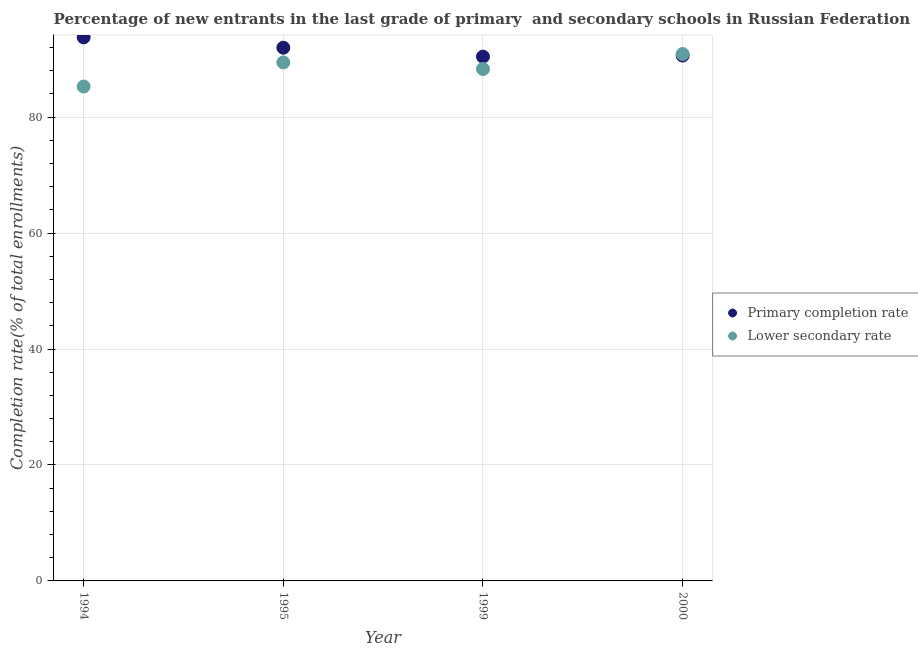How many different coloured dotlines are there?
Keep it short and to the point. 2. Is the number of dotlines equal to the number of legend labels?
Make the answer very short. Yes. What is the completion rate in secondary schools in 1999?
Give a very brief answer. 88.31. Across all years, what is the maximum completion rate in secondary schools?
Keep it short and to the point. 90.9. Across all years, what is the minimum completion rate in primary schools?
Offer a terse response. 90.45. In which year was the completion rate in primary schools maximum?
Give a very brief answer. 1994. In which year was the completion rate in secondary schools minimum?
Give a very brief answer. 1994. What is the total completion rate in primary schools in the graph?
Provide a succinct answer. 366.83. What is the difference between the completion rate in secondary schools in 1995 and that in 2000?
Your answer should be very brief. -1.45. What is the difference between the completion rate in primary schools in 1994 and the completion rate in secondary schools in 2000?
Offer a very short reply. 2.88. What is the average completion rate in secondary schools per year?
Make the answer very short. 88.49. In the year 2000, what is the difference between the completion rate in secondary schools and completion rate in primary schools?
Keep it short and to the point. 0.26. In how many years, is the completion rate in secondary schools greater than 68 %?
Offer a very short reply. 4. What is the ratio of the completion rate in primary schools in 1999 to that in 2000?
Make the answer very short. 1. Is the difference between the completion rate in secondary schools in 1994 and 2000 greater than the difference between the completion rate in primary schools in 1994 and 2000?
Make the answer very short. No. What is the difference between the highest and the second highest completion rate in secondary schools?
Your response must be concise. 1.45. What is the difference between the highest and the lowest completion rate in secondary schools?
Keep it short and to the point. 5.61. Does the completion rate in secondary schools monotonically increase over the years?
Provide a short and direct response. No. How many years are there in the graph?
Offer a terse response. 4. What is the difference between two consecutive major ticks on the Y-axis?
Your answer should be compact. 20. Are the values on the major ticks of Y-axis written in scientific E-notation?
Make the answer very short. No. Does the graph contain any zero values?
Offer a very short reply. No. What is the title of the graph?
Provide a short and direct response. Percentage of new entrants in the last grade of primary  and secondary schools in Russian Federation. What is the label or title of the Y-axis?
Provide a short and direct response. Completion rate(% of total enrollments). What is the Completion rate(% of total enrollments) in Primary completion rate in 1994?
Give a very brief answer. 93.77. What is the Completion rate(% of total enrollments) of Lower secondary rate in 1994?
Ensure brevity in your answer.  85.29. What is the Completion rate(% of total enrollments) in Primary completion rate in 1995?
Offer a terse response. 91.98. What is the Completion rate(% of total enrollments) in Lower secondary rate in 1995?
Keep it short and to the point. 89.45. What is the Completion rate(% of total enrollments) of Primary completion rate in 1999?
Your answer should be very brief. 90.45. What is the Completion rate(% of total enrollments) in Lower secondary rate in 1999?
Your answer should be very brief. 88.31. What is the Completion rate(% of total enrollments) of Primary completion rate in 2000?
Give a very brief answer. 90.63. What is the Completion rate(% of total enrollments) in Lower secondary rate in 2000?
Make the answer very short. 90.9. Across all years, what is the maximum Completion rate(% of total enrollments) in Primary completion rate?
Make the answer very short. 93.77. Across all years, what is the maximum Completion rate(% of total enrollments) of Lower secondary rate?
Provide a succinct answer. 90.9. Across all years, what is the minimum Completion rate(% of total enrollments) of Primary completion rate?
Offer a very short reply. 90.45. Across all years, what is the minimum Completion rate(% of total enrollments) of Lower secondary rate?
Keep it short and to the point. 85.29. What is the total Completion rate(% of total enrollments) in Primary completion rate in the graph?
Your answer should be compact. 366.83. What is the total Completion rate(% of total enrollments) in Lower secondary rate in the graph?
Offer a very short reply. 353.94. What is the difference between the Completion rate(% of total enrollments) in Primary completion rate in 1994 and that in 1995?
Make the answer very short. 1.79. What is the difference between the Completion rate(% of total enrollments) in Lower secondary rate in 1994 and that in 1995?
Keep it short and to the point. -4.16. What is the difference between the Completion rate(% of total enrollments) in Primary completion rate in 1994 and that in 1999?
Offer a terse response. 3.33. What is the difference between the Completion rate(% of total enrollments) of Lower secondary rate in 1994 and that in 1999?
Provide a succinct answer. -3.02. What is the difference between the Completion rate(% of total enrollments) in Primary completion rate in 1994 and that in 2000?
Ensure brevity in your answer.  3.14. What is the difference between the Completion rate(% of total enrollments) of Lower secondary rate in 1994 and that in 2000?
Your answer should be very brief. -5.61. What is the difference between the Completion rate(% of total enrollments) of Primary completion rate in 1995 and that in 1999?
Keep it short and to the point. 1.54. What is the difference between the Completion rate(% of total enrollments) of Lower secondary rate in 1995 and that in 1999?
Provide a short and direct response. 1.14. What is the difference between the Completion rate(% of total enrollments) in Primary completion rate in 1995 and that in 2000?
Your response must be concise. 1.35. What is the difference between the Completion rate(% of total enrollments) of Lower secondary rate in 1995 and that in 2000?
Your response must be concise. -1.45. What is the difference between the Completion rate(% of total enrollments) of Primary completion rate in 1999 and that in 2000?
Give a very brief answer. -0.18. What is the difference between the Completion rate(% of total enrollments) in Lower secondary rate in 1999 and that in 2000?
Your response must be concise. -2.59. What is the difference between the Completion rate(% of total enrollments) in Primary completion rate in 1994 and the Completion rate(% of total enrollments) in Lower secondary rate in 1995?
Keep it short and to the point. 4.33. What is the difference between the Completion rate(% of total enrollments) in Primary completion rate in 1994 and the Completion rate(% of total enrollments) in Lower secondary rate in 1999?
Provide a short and direct response. 5.46. What is the difference between the Completion rate(% of total enrollments) of Primary completion rate in 1994 and the Completion rate(% of total enrollments) of Lower secondary rate in 2000?
Your answer should be compact. 2.88. What is the difference between the Completion rate(% of total enrollments) of Primary completion rate in 1995 and the Completion rate(% of total enrollments) of Lower secondary rate in 1999?
Offer a terse response. 3.67. What is the difference between the Completion rate(% of total enrollments) of Primary completion rate in 1995 and the Completion rate(% of total enrollments) of Lower secondary rate in 2000?
Your response must be concise. 1.09. What is the difference between the Completion rate(% of total enrollments) of Primary completion rate in 1999 and the Completion rate(% of total enrollments) of Lower secondary rate in 2000?
Make the answer very short. -0.45. What is the average Completion rate(% of total enrollments) of Primary completion rate per year?
Make the answer very short. 91.71. What is the average Completion rate(% of total enrollments) of Lower secondary rate per year?
Provide a short and direct response. 88.49. In the year 1994, what is the difference between the Completion rate(% of total enrollments) in Primary completion rate and Completion rate(% of total enrollments) in Lower secondary rate?
Offer a very short reply. 8.48. In the year 1995, what is the difference between the Completion rate(% of total enrollments) of Primary completion rate and Completion rate(% of total enrollments) of Lower secondary rate?
Your answer should be compact. 2.54. In the year 1999, what is the difference between the Completion rate(% of total enrollments) in Primary completion rate and Completion rate(% of total enrollments) in Lower secondary rate?
Your response must be concise. 2.14. In the year 2000, what is the difference between the Completion rate(% of total enrollments) in Primary completion rate and Completion rate(% of total enrollments) in Lower secondary rate?
Offer a very short reply. -0.27. What is the ratio of the Completion rate(% of total enrollments) of Primary completion rate in 1994 to that in 1995?
Provide a short and direct response. 1.02. What is the ratio of the Completion rate(% of total enrollments) of Lower secondary rate in 1994 to that in 1995?
Your answer should be compact. 0.95. What is the ratio of the Completion rate(% of total enrollments) in Primary completion rate in 1994 to that in 1999?
Make the answer very short. 1.04. What is the ratio of the Completion rate(% of total enrollments) of Lower secondary rate in 1994 to that in 1999?
Your answer should be very brief. 0.97. What is the ratio of the Completion rate(% of total enrollments) of Primary completion rate in 1994 to that in 2000?
Your answer should be compact. 1.03. What is the ratio of the Completion rate(% of total enrollments) of Lower secondary rate in 1994 to that in 2000?
Make the answer very short. 0.94. What is the ratio of the Completion rate(% of total enrollments) in Primary completion rate in 1995 to that in 1999?
Your answer should be very brief. 1.02. What is the ratio of the Completion rate(% of total enrollments) of Lower secondary rate in 1995 to that in 1999?
Your answer should be compact. 1.01. What is the ratio of the Completion rate(% of total enrollments) of Primary completion rate in 1995 to that in 2000?
Your answer should be compact. 1.01. What is the ratio of the Completion rate(% of total enrollments) of Lower secondary rate in 1995 to that in 2000?
Keep it short and to the point. 0.98. What is the ratio of the Completion rate(% of total enrollments) of Lower secondary rate in 1999 to that in 2000?
Keep it short and to the point. 0.97. What is the difference between the highest and the second highest Completion rate(% of total enrollments) of Primary completion rate?
Provide a short and direct response. 1.79. What is the difference between the highest and the second highest Completion rate(% of total enrollments) in Lower secondary rate?
Keep it short and to the point. 1.45. What is the difference between the highest and the lowest Completion rate(% of total enrollments) in Primary completion rate?
Offer a very short reply. 3.33. What is the difference between the highest and the lowest Completion rate(% of total enrollments) in Lower secondary rate?
Your response must be concise. 5.61. 